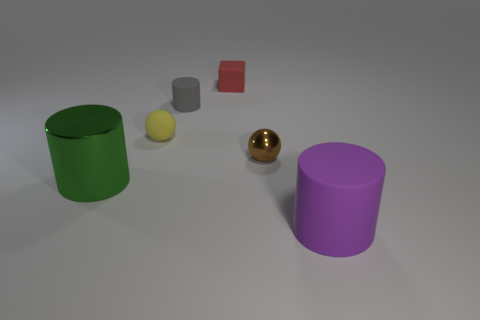Are there any other things that have the same color as the shiny cylinder?
Offer a very short reply. No. Do the sphere to the left of the gray matte thing and the large thing that is behind the purple rubber cylinder have the same color?
Keep it short and to the point. No. Are there any spheres?
Keep it short and to the point. Yes. Is there a purple thing that has the same material as the tiny cylinder?
Provide a succinct answer. Yes. Is there any other thing that has the same material as the small cylinder?
Your answer should be very brief. Yes. What color is the small rubber cylinder?
Offer a very short reply. Gray. There is a rubber sphere that is the same size as the rubber cube; what color is it?
Ensure brevity in your answer.  Yellow. How many matte objects are things or purple cylinders?
Ensure brevity in your answer.  4. What number of big cylinders are right of the tiny matte block and to the left of the purple object?
Provide a succinct answer. 0. Is there anything else that has the same shape as the small red object?
Provide a short and direct response. No. 